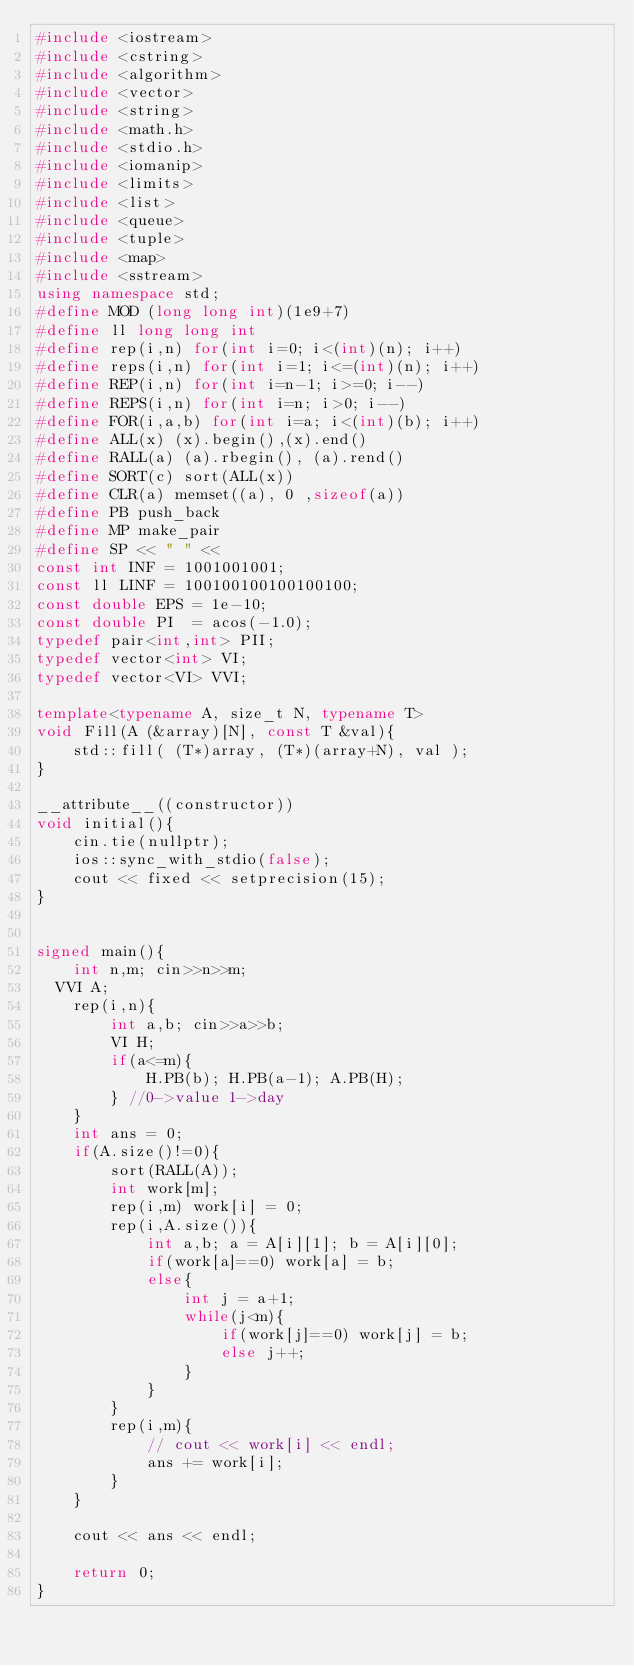<code> <loc_0><loc_0><loc_500><loc_500><_C++_>#include <iostream>
#include <cstring>
#include <algorithm>
#include <vector>
#include <string>
#include <math.h>
#include <stdio.h>
#include <iomanip>
#include <limits>
#include <list>
#include <queue>
#include <tuple>
#include <map>
#include <sstream>
using namespace std;
#define MOD (long long int)(1e9+7)
#define ll long long int
#define rep(i,n) for(int i=0; i<(int)(n); i++)
#define reps(i,n) for(int i=1; i<=(int)(n); i++)
#define REP(i,n) for(int i=n-1; i>=0; i--)
#define REPS(i,n) for(int i=n; i>0; i--)
#define FOR(i,a,b) for(int i=a; i<(int)(b); i++)
#define ALL(x) (x).begin(),(x).end()
#define RALL(a) (a).rbegin(), (a).rend()
#define SORT(c) sort(ALL(x))
#define CLR(a) memset((a), 0 ,sizeof(a))
#define PB push_back
#define MP make_pair
#define SP << " " <<
const int INF = 1001001001;
const ll LINF = 100100100100100100;
const double EPS = 1e-10;
const double PI  = acos(-1.0);
typedef pair<int,int> PII;
typedef vector<int> VI;
typedef vector<VI> VVI;

template<typename A, size_t N, typename T>
void Fill(A (&array)[N], const T &val){
    std::fill( (T*)array, (T*)(array+N), val );
}

__attribute__((constructor))
void initial(){
	cin.tie(nullptr);
	ios::sync_with_stdio(false);
	cout << fixed << setprecision(15);
}


signed main(){
	int n,m; cin>>n>>m;
  VVI A;
	rep(i,n){
		int a,b; cin>>a>>b;
		VI H;
		if(a<=m){
			H.PB(b); H.PB(a-1); A.PB(H);
		} //0->value 1->day
	}
	int ans = 0;
	if(A.size()!=0){
		sort(RALL(A));
		int work[m];
		rep(i,m) work[i] = 0;
		rep(i,A.size()){
			int a,b; a = A[i][1]; b = A[i][0];
			if(work[a]==0) work[a] = b;
			else{
				int j = a+1;
				while(j<m){
					if(work[j]==0) work[j] = b;
					else j++;
				}
			}
		}
		rep(i,m){
			// cout << work[i] << endl;
			ans += work[i];
		}
	}

	cout << ans << endl;

	return 0;
}
</code> 